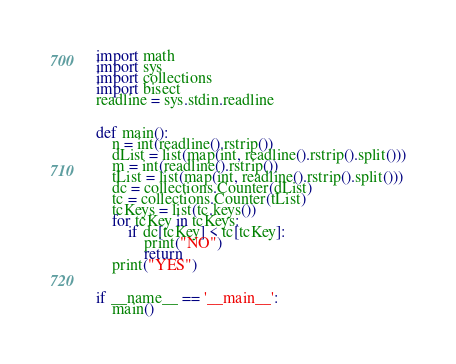<code> <loc_0><loc_0><loc_500><loc_500><_Python_>import math
import sys
import collections
import bisect
readline = sys.stdin.readline


def main():
    n = int(readline().rstrip())
    dList = list(map(int, readline().rstrip().split()))
    m = int(readline().rstrip())
    tList = list(map(int, readline().rstrip().split()))
    dc = collections.Counter(dList)
    tc = collections.Counter(tList)
    tcKeys = list(tc.keys())
    for tcKey in tcKeys:
        if dc[tcKey] < tc[tcKey]:
            print("NO")
            return
    print("YES")


if __name__ == '__main__':
    main()
</code> 